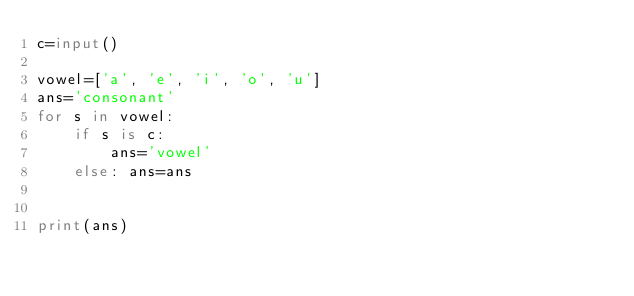Convert code to text. <code><loc_0><loc_0><loc_500><loc_500><_Python_>c=input()

vowel=['a', 'e', 'i', 'o', 'u']
ans='consonant'
for s in vowel:
    if s is c:
        ans='vowel'
    else: ans=ans
       
    
print(ans)</code> 